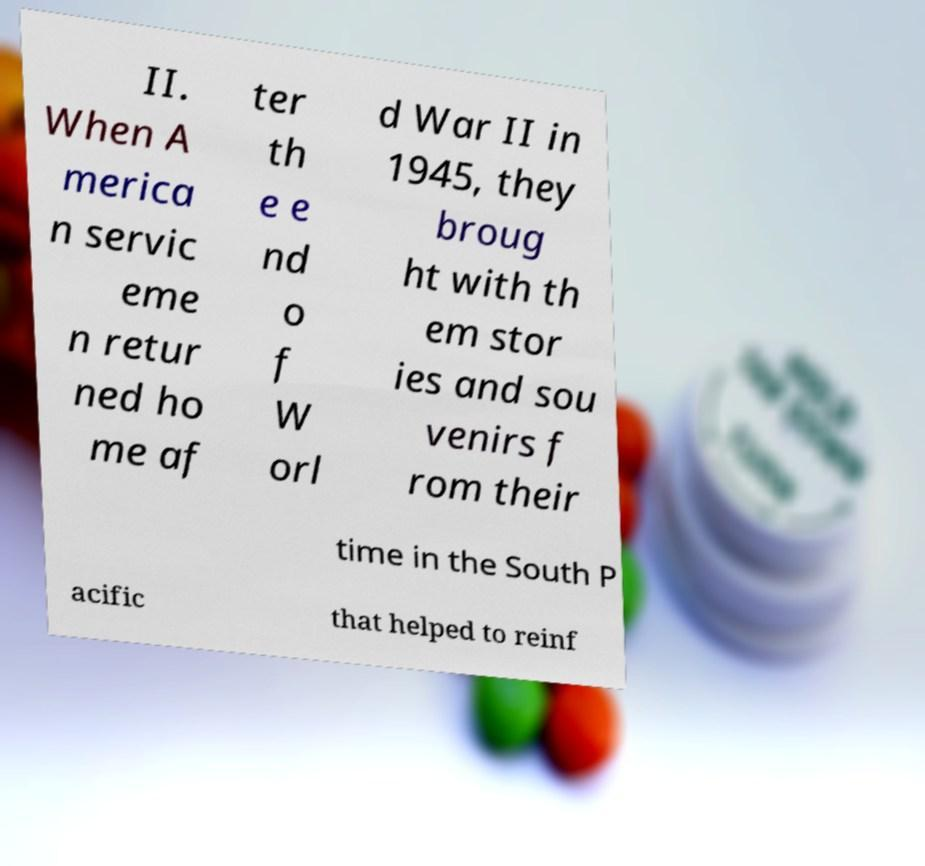Could you assist in decoding the text presented in this image and type it out clearly? II. When A merica n servic eme n retur ned ho me af ter th e e nd o f W orl d War II in 1945, they broug ht with th em stor ies and sou venirs f rom their time in the South P acific that helped to reinf 